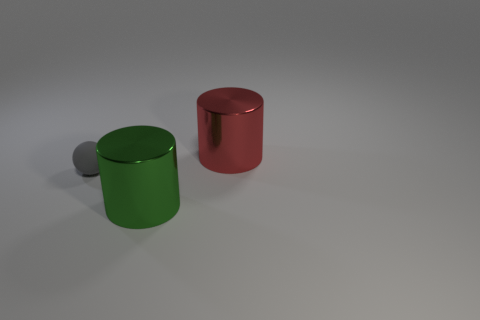Assuming these objects were part of a larger narrative, what story could they tell? If we imagine these objects as characters or elements in a narrative, the two large cylinders might represent individuals or forces, with the red one symbolizing a character of action and boldness, and the green one representing a character of calmness and stability. The gray spheres could symbolize challenges, offspring, or followers. Such a narrative could unfold around themes of balance, contrast, or the interaction between opposites. 